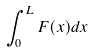<formula> <loc_0><loc_0><loc_500><loc_500>\int _ { 0 } ^ { L } F ( x ) d x</formula> 